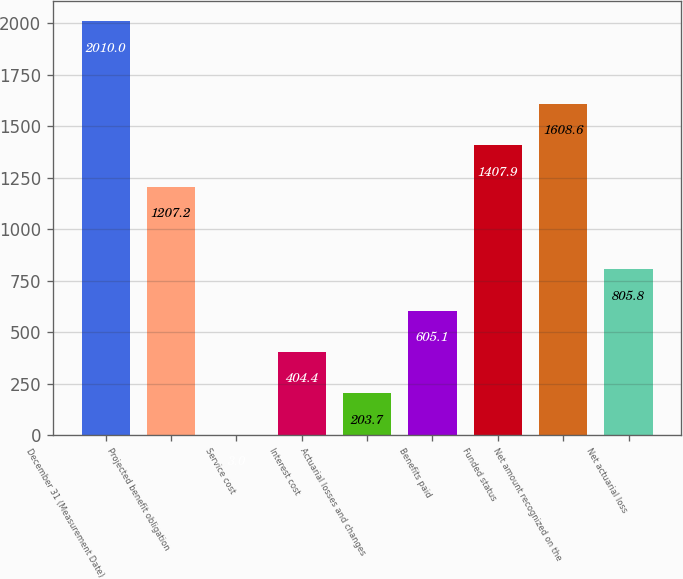<chart> <loc_0><loc_0><loc_500><loc_500><bar_chart><fcel>December 31 (Measurement Date)<fcel>Projected benefit obligation<fcel>Service cost<fcel>Interest cost<fcel>Actuarial losses and changes<fcel>Benefits paid<fcel>Funded status<fcel>Net amount recognized on the<fcel>Net actuarial loss<nl><fcel>2010<fcel>1207.2<fcel>3<fcel>404.4<fcel>203.7<fcel>605.1<fcel>1407.9<fcel>1608.6<fcel>805.8<nl></chart> 